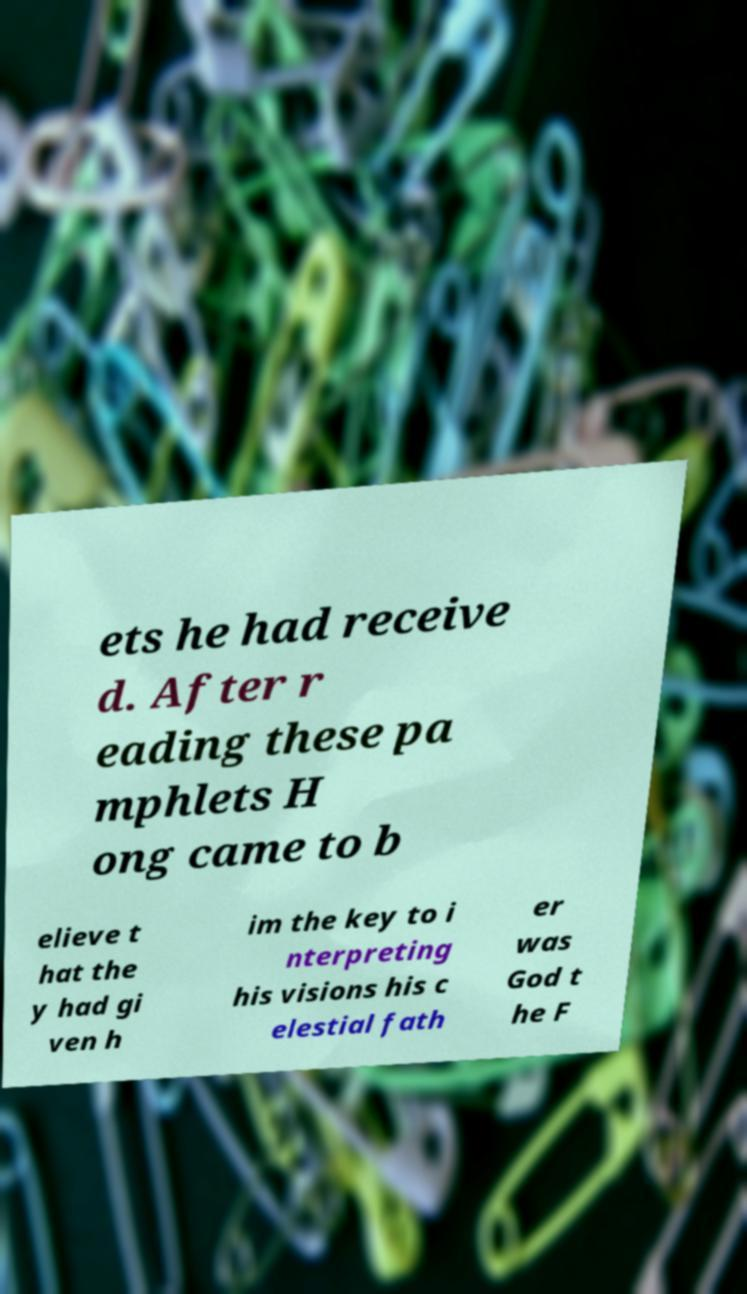Could you extract and type out the text from this image? ets he had receive d. After r eading these pa mphlets H ong came to b elieve t hat the y had gi ven h im the key to i nterpreting his visions his c elestial fath er was God t he F 